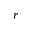Convert formula to latex. <formula><loc_0><loc_0><loc_500><loc_500>r</formula> 